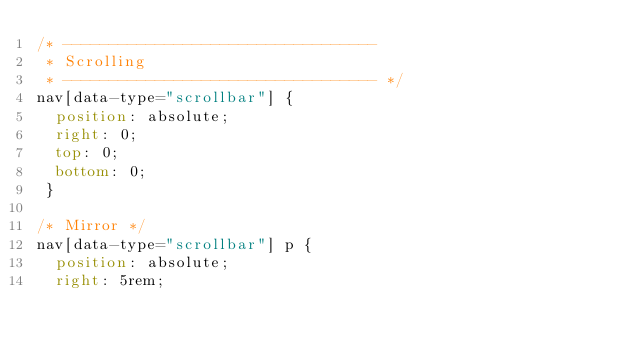Convert code to text. <code><loc_0><loc_0><loc_500><loc_500><_CSS_>/* ----------------------------------
 * Scrolling
 * ---------------------------------- */
nav[data-type="scrollbar"] {
  position: absolute;
  right: 0;
  top: 0;
  bottom: 0;
 }

/* Mirror */
nav[data-type="scrollbar"] p {
  position: absolute;
  right: 5rem;</code> 